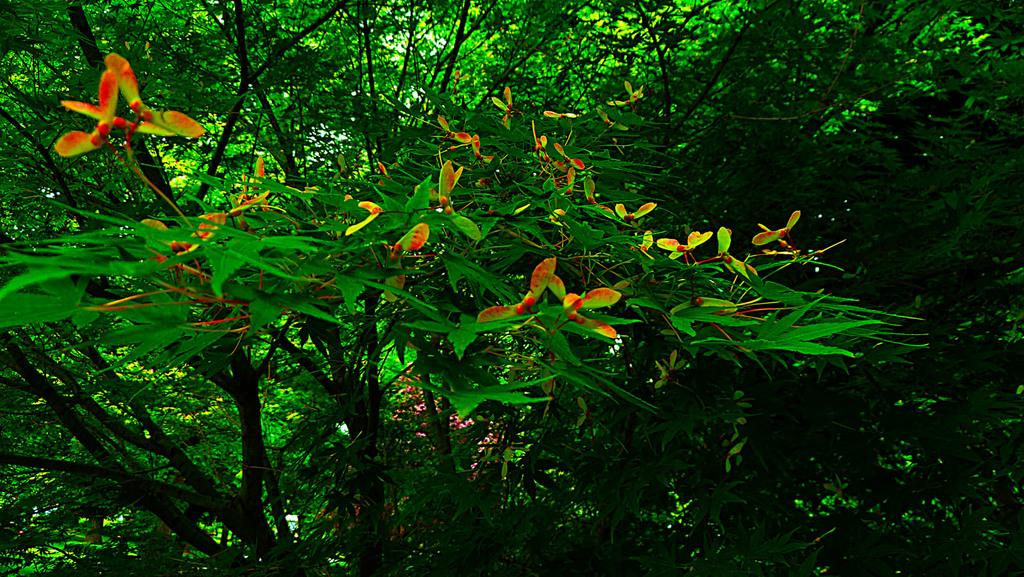What is the state of the trees in the image? There are buds on the trees in the image. What color are the buds on the trees? The buds are in red color. How many trees can be seen in the background of the image? There are many trees visible in the background of the image. How many insects are crawling on the arm in the image? There is no arm or insects present in the image. 